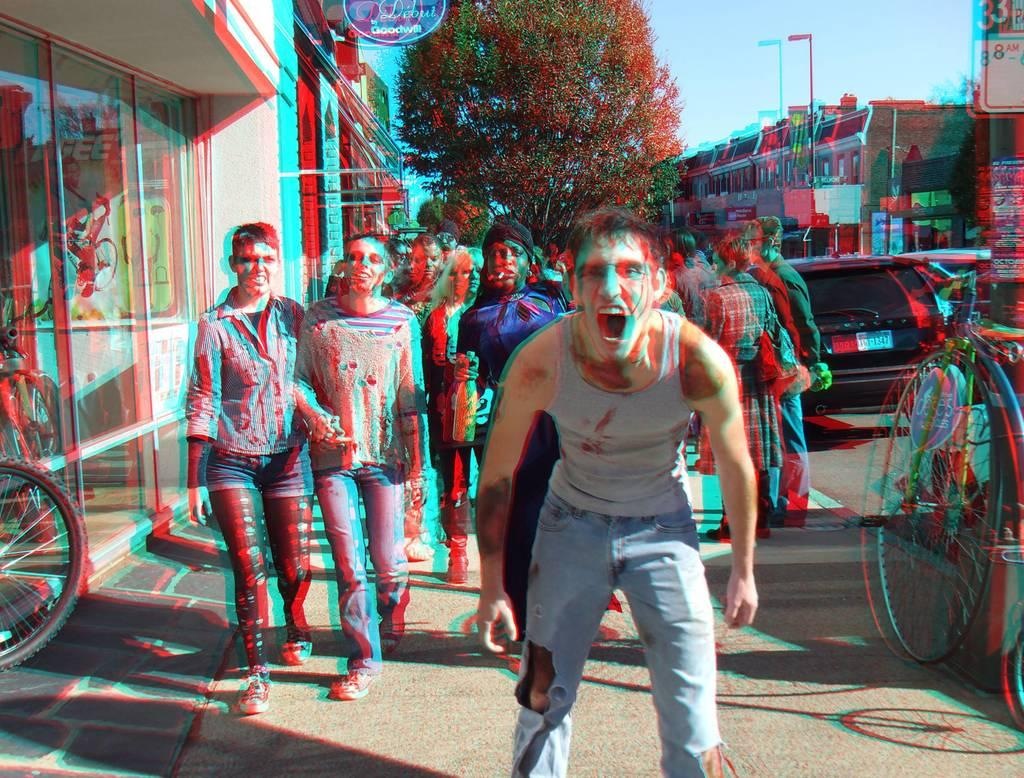How many people are in the image? There is a group of people in the image, but the exact number cannot be determined from the provided facts. What are the people in the image doing? The provided facts do not specify what the people are doing. What can be seen in the background of the image? There are buildings, trees, and vehicles in the background of the image. What type of twig is being used as a knee support by the person on the bicycle in the image? There is no twig or person on a bicycle present in the image. How many flies can be seen buzzing around the people in the image? There are no flies present in the image. 